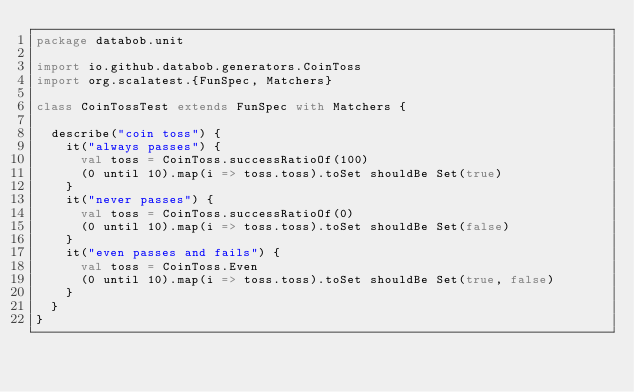Convert code to text. <code><loc_0><loc_0><loc_500><loc_500><_Scala_>package databob.unit

import io.github.databob.generators.CoinToss
import org.scalatest.{FunSpec, Matchers}

class CoinTossTest extends FunSpec with Matchers {

  describe("coin toss") {
    it("always passes") {
      val toss = CoinToss.successRatioOf(100)
      (0 until 10).map(i => toss.toss).toSet shouldBe Set(true)
    }
    it("never passes") {
      val toss = CoinToss.successRatioOf(0)
      (0 until 10).map(i => toss.toss).toSet shouldBe Set(false)
    }
    it("even passes and fails") {
      val toss = CoinToss.Even
      (0 until 10).map(i => toss.toss).toSet shouldBe Set(true, false)
    }
  }
}
</code> 